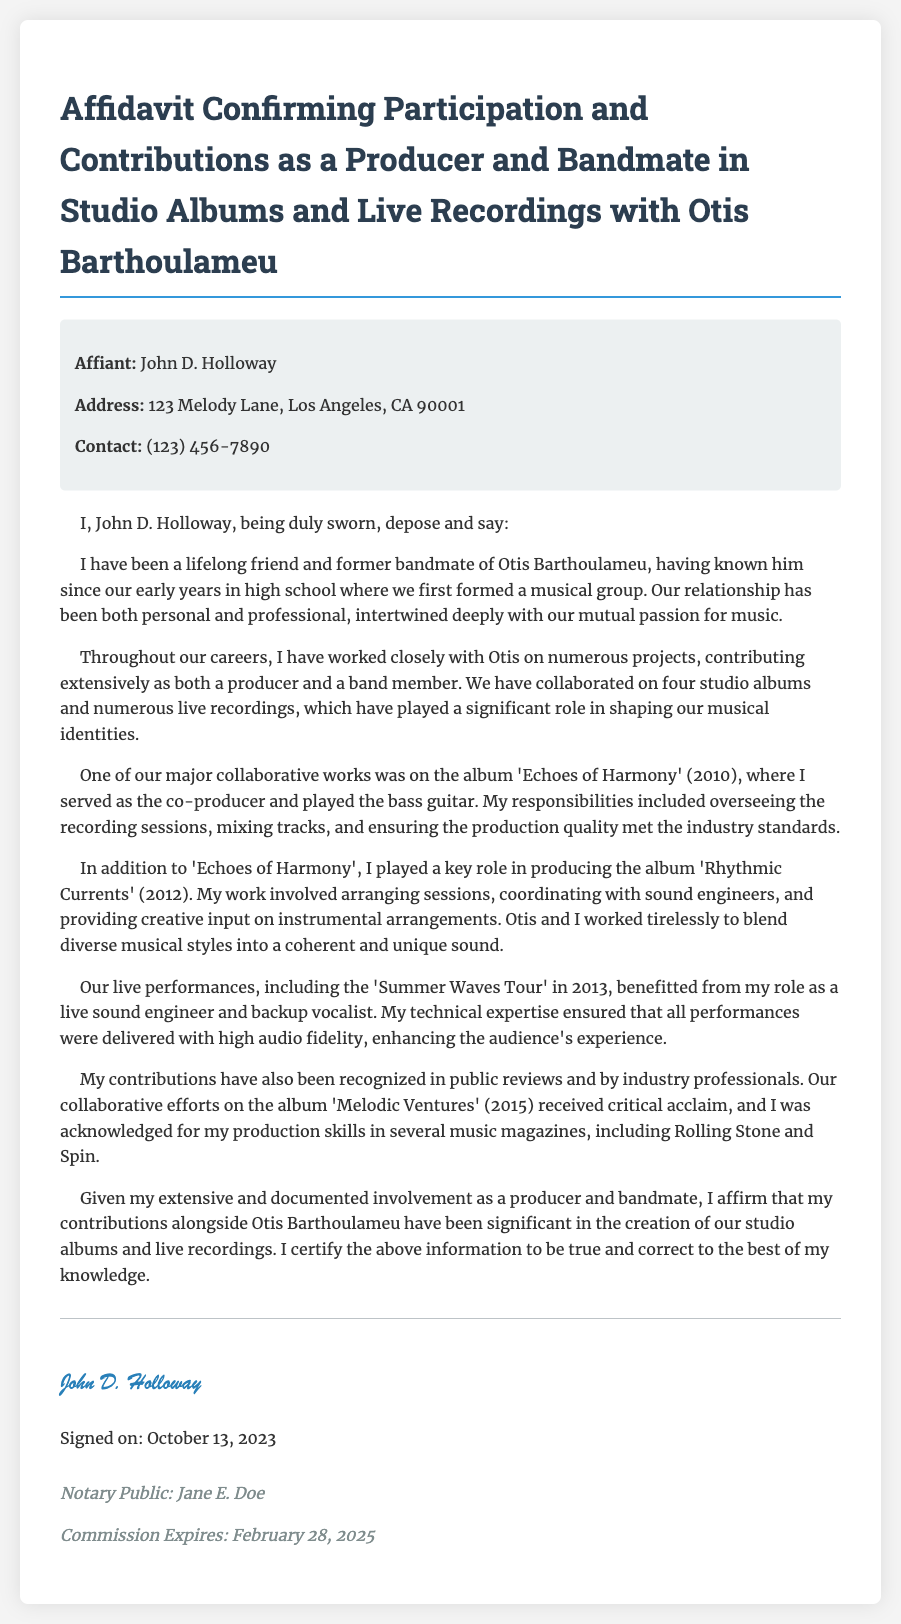What is the name of the affiant? The document states that the affiant's name is John D. Holloway.
Answer: John D. Holloway What is the address of the affiant? The document provides the address as 123 Melody Lane, Los Angeles, CA 90001.
Answer: 123 Melody Lane, Los Angeles, CA 90001 In which year was the album 'Echoes of Harmony' released? The document mentions that 'Echoes of Harmony' was released in the year 2010.
Answer: 2010 What role did John D. Holloway have in producing 'Rhythmic Currents'? The document states that he played a key role in producing the album, including arranging sessions.
Answer: Key role What is the name of the tour mentioned in the affidavit? The document indicates that the tour mentioned is the 'Summer Waves Tour' in 2013.
Answer: Summer Waves Tour Which music magazines recognized John D. Holloway's production skills? The affidavit cites that his skills were acknowledged in Rolling Stone and Spin.
Answer: Rolling Stone and Spin How many studio albums did John D. Holloway collaborate on with Otis Barthoulameu? The document states that he collaborated on four studio albums with Otis Barthoulameu.
Answer: Four Who is the notary public mentioned at the end of the document? The document names Jane E. Doe as the notary public.
Answer: Jane E. Doe When was the affidavit signed? The affidavit indicates that it was signed on October 13, 2023.
Answer: October 13, 2023 